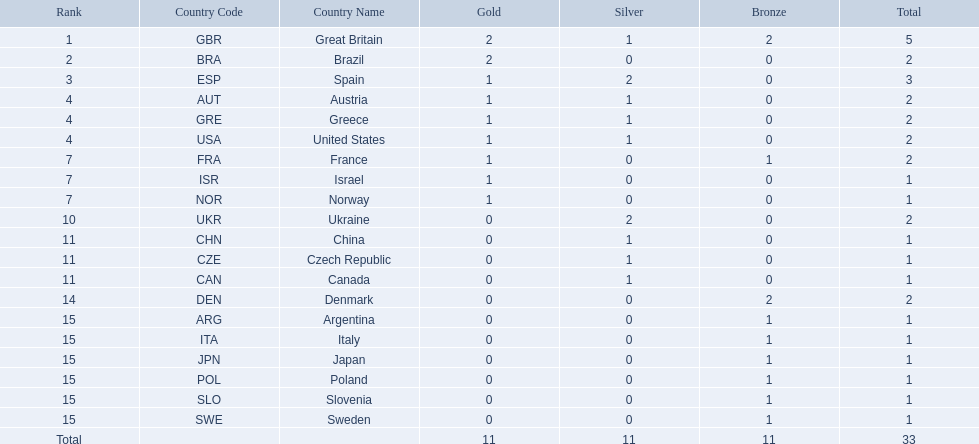What are all of the countries? Great Britain (GBR), Brazil (BRA), Spain (ESP), Austria (AUT), Greece (GRE), United States (USA), France (FRA), Israel (ISR), Norway (NOR), Ukraine (UKR), China (CHN), Czech Republic (CZE), Canada (CAN), Denmark (DEN), Argentina (ARG), Italy (ITA), Japan (JPN), Poland (POL), Slovenia (SLO), Sweden (SWE). Which ones earned a medal? Great Britain (GBR), Brazil (BRA), Spain (ESP), Austria (AUT), Greece (GRE), United States (USA), France (FRA), Israel (ISR), Norway (NOR), Ukraine (UKR), China (CHN), Czech Republic (CZE), Canada (CAN), Denmark (DEN), Argentina (ARG), Italy (ITA), Japan (JPN), Poland (POL), Slovenia (SLO), Sweden (SWE). Which countries earned at least 3 medals? Great Britain (GBR), Spain (ESP). Which country earned 3 medals? Spain (ESP). 